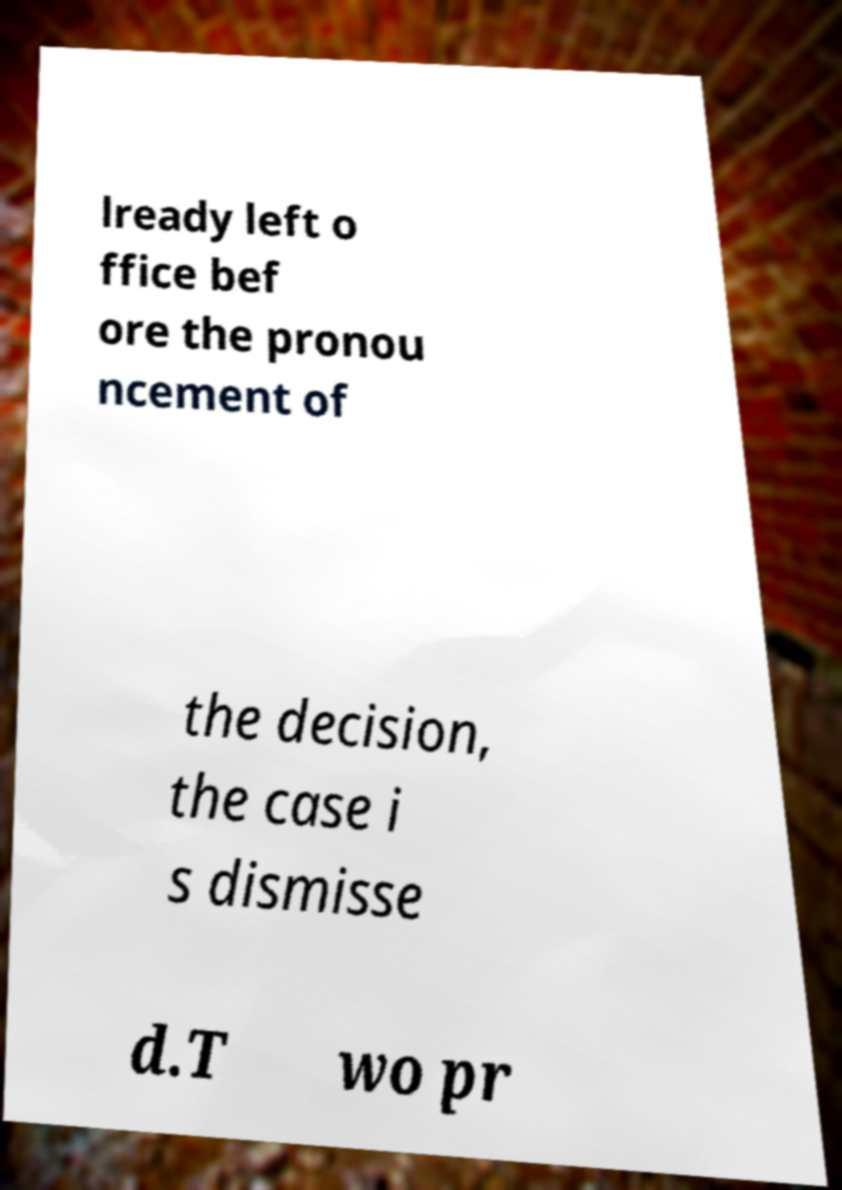Can you accurately transcribe the text from the provided image for me? lready left o ffice bef ore the pronou ncement of the decision, the case i s dismisse d.T wo pr 